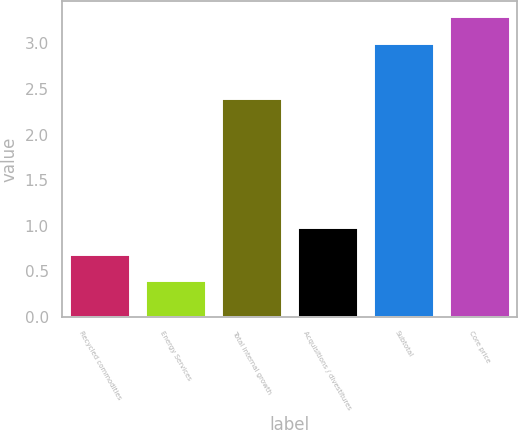Convert chart. <chart><loc_0><loc_0><loc_500><loc_500><bar_chart><fcel>Recycled commodities<fcel>Energy Services<fcel>Total internal growth<fcel>Acquisitions / divestitures<fcel>Subtotal<fcel>Core price<nl><fcel>0.69<fcel>0.4<fcel>2.4<fcel>0.98<fcel>3<fcel>3.3<nl></chart> 